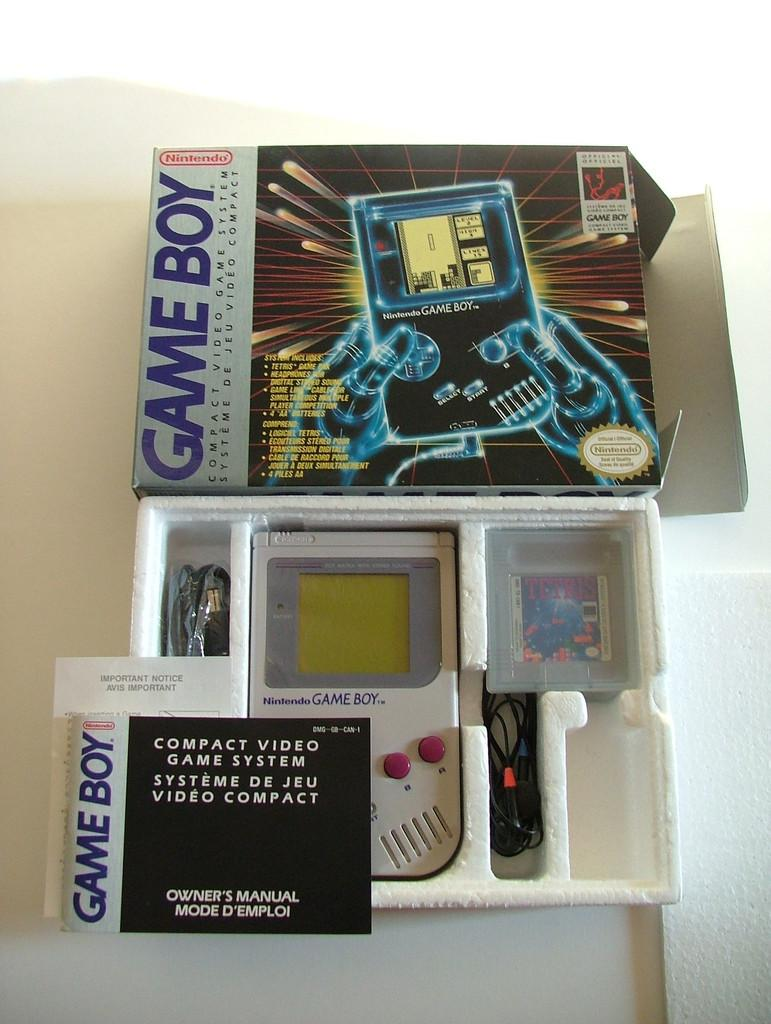Provide a one-sentence caption for the provided image. A  Gameboy complete with its' original packaging. 